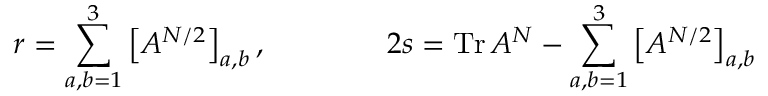Convert formula to latex. <formula><loc_0><loc_0><loc_500><loc_500>r = \sum _ { a , b = 1 } ^ { 3 } \left [ A ^ { N / 2 } \right ] _ { a , b } , \quad 2 s = T r \, A ^ { N } - \sum _ { a , b = 1 } ^ { 3 } \left [ A ^ { N / 2 } \right ] _ { a , b }</formula> 